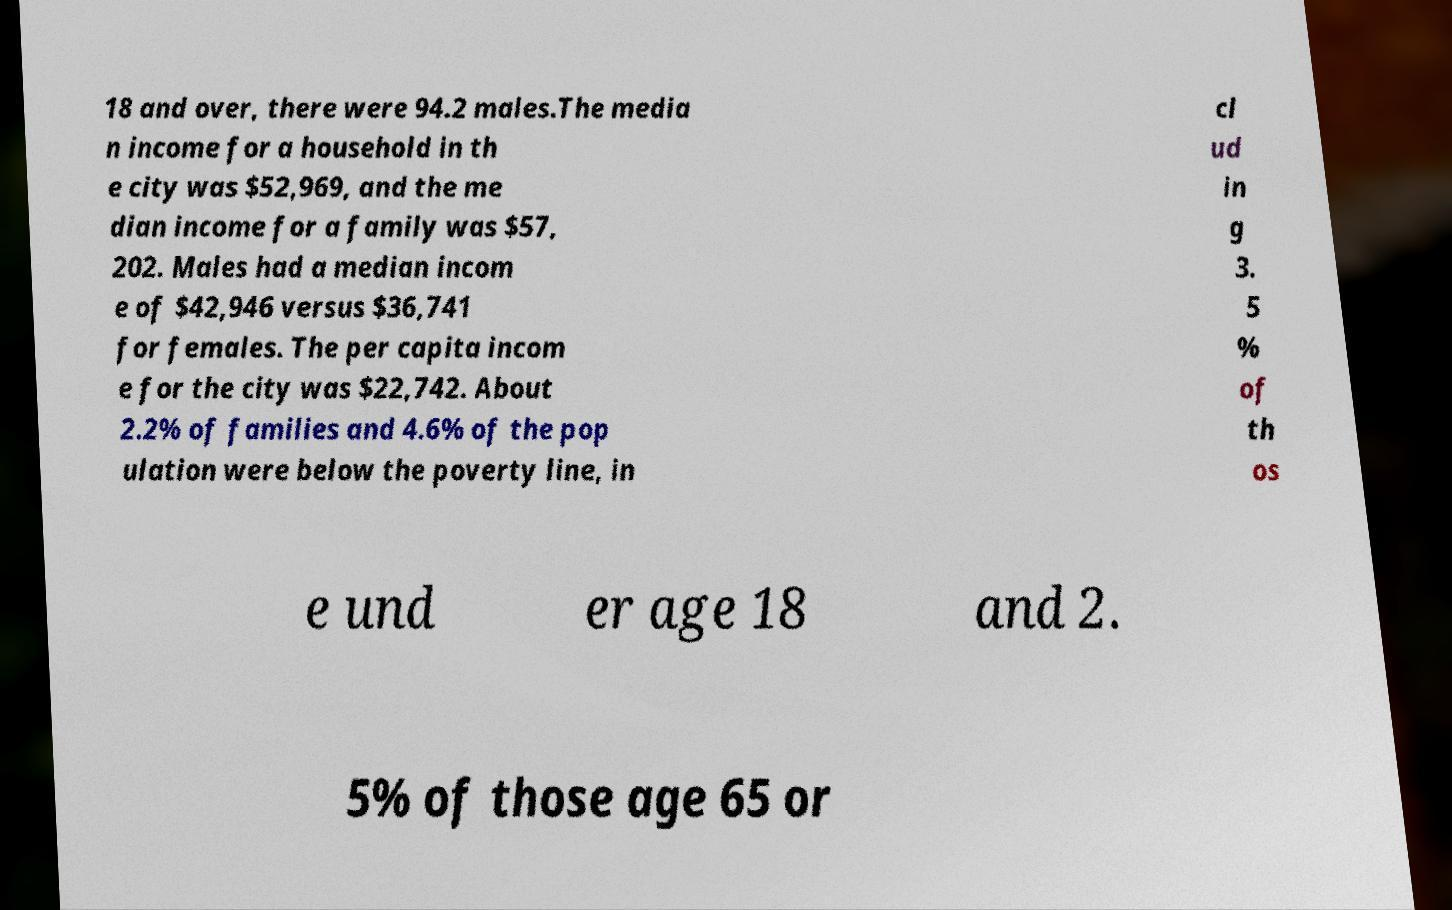Please identify and transcribe the text found in this image. 18 and over, there were 94.2 males.The media n income for a household in th e city was $52,969, and the me dian income for a family was $57, 202. Males had a median incom e of $42,946 versus $36,741 for females. The per capita incom e for the city was $22,742. About 2.2% of families and 4.6% of the pop ulation were below the poverty line, in cl ud in g 3. 5 % of th os e und er age 18 and 2. 5% of those age 65 or 